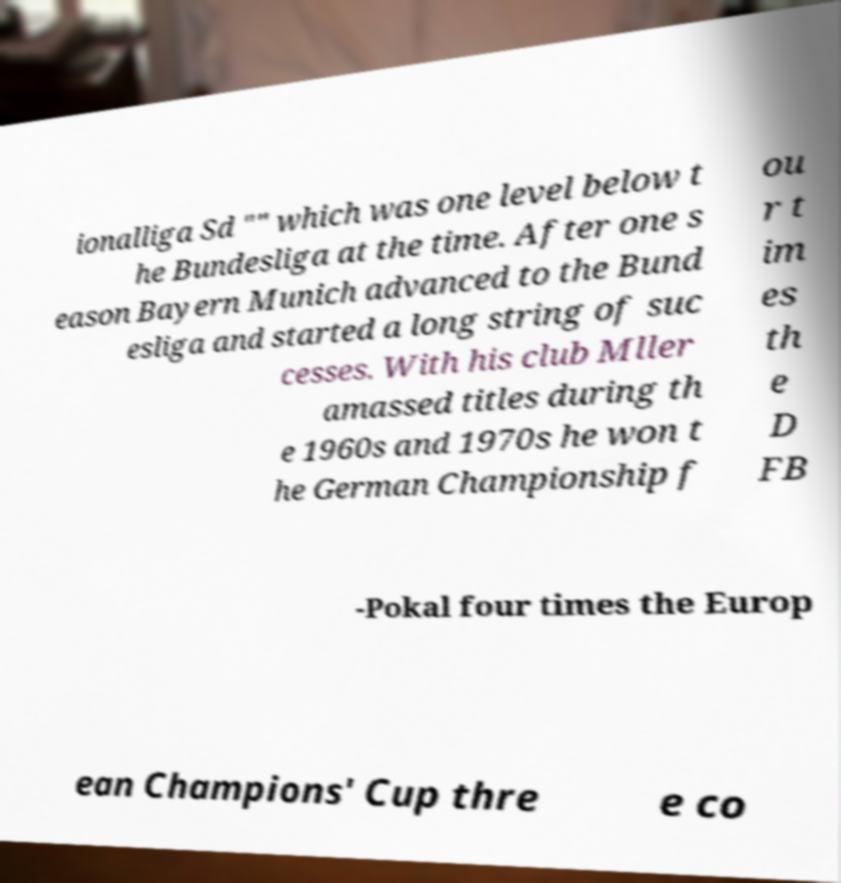Could you extract and type out the text from this image? ionalliga Sd "" which was one level below t he Bundesliga at the time. After one s eason Bayern Munich advanced to the Bund esliga and started a long string of suc cesses. With his club Mller amassed titles during th e 1960s and 1970s he won t he German Championship f ou r t im es th e D FB -Pokal four times the Europ ean Champions' Cup thre e co 